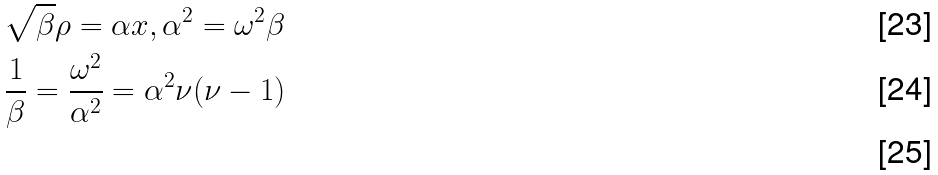Convert formula to latex. <formula><loc_0><loc_0><loc_500><loc_500>& \sqrt { \beta } \rho = \alpha x , \alpha ^ { 2 } = \omega ^ { 2 } \beta \\ & \frac { 1 } { \beta } = \frac { \omega ^ { 2 } } { \alpha ^ { 2 } } = \alpha ^ { 2 } \nu ( \nu - 1 ) \\</formula> 